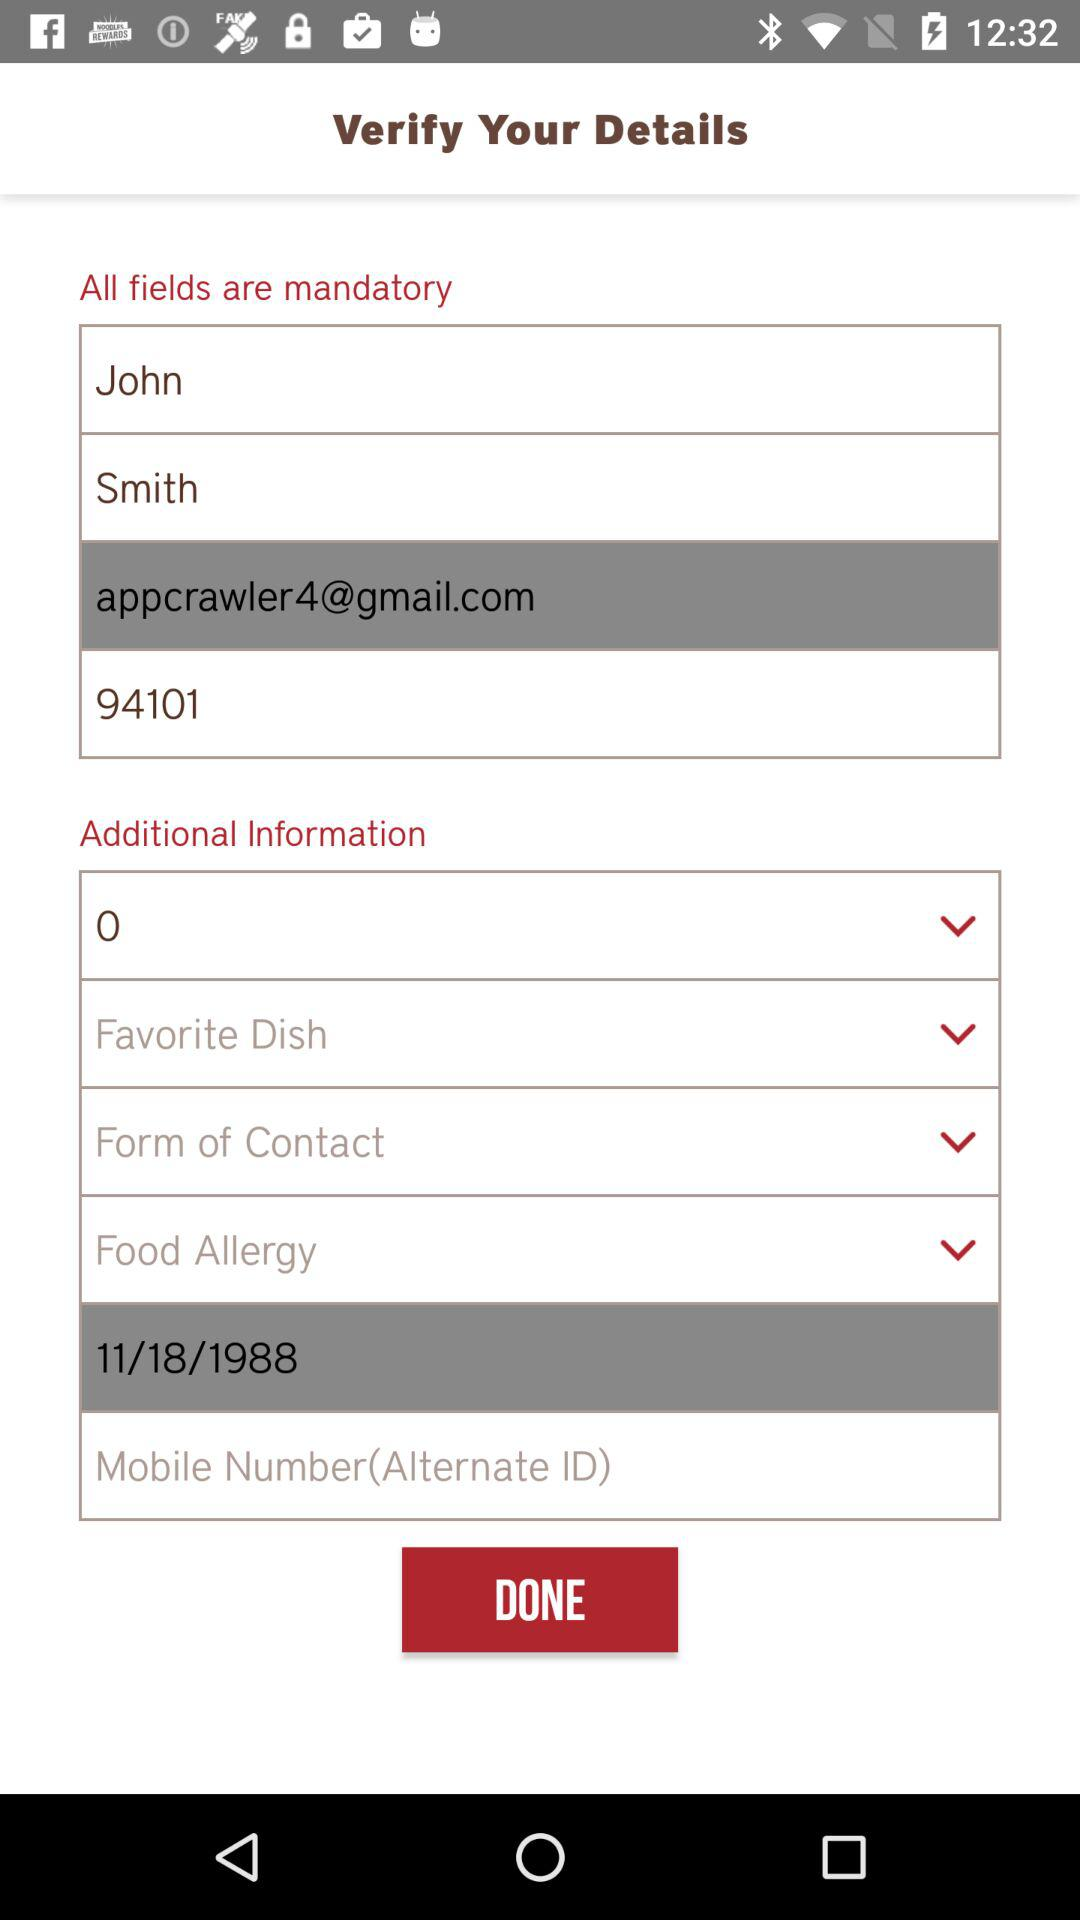What is the date of birth? The date of birth is November 18, 1988. 